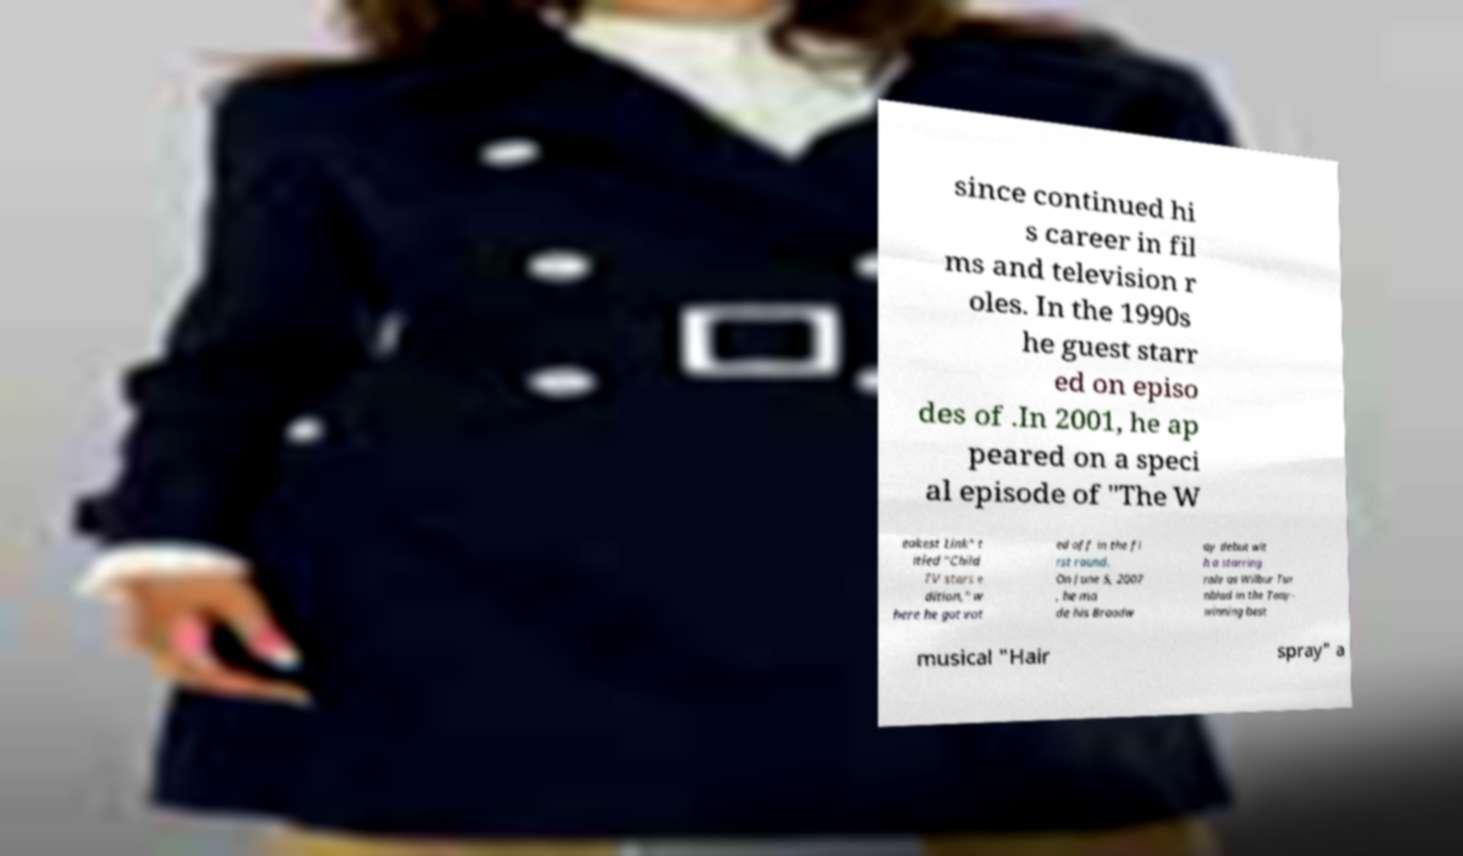Could you extract and type out the text from this image? since continued hi s career in fil ms and television r oles. In the 1990s he guest starr ed on episo des of .In 2001, he ap peared on a speci al episode of "The W eakest Link" t itled "Child TV stars e dition," w here he got vot ed off in the fi rst round. On June 5, 2007 , he ma de his Broadw ay debut wit h a starring role as Wilbur Tur nblad in the Tony- winning best musical "Hair spray" a 